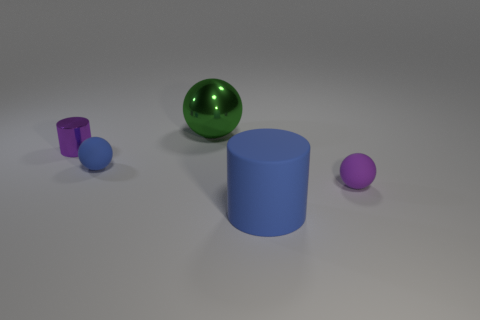There is a blue object that is made of the same material as the blue ball; what shape is it?
Offer a terse response. Cylinder. What is the color of the object that is both on the right side of the tiny purple cylinder and behind the small blue thing?
Your answer should be very brief. Green. Is the material of the purple object right of the large blue thing the same as the green ball?
Give a very brief answer. No. Are there fewer small purple shiny cylinders that are behind the big shiny thing than small metallic things?
Make the answer very short. Yes. Is there a blue ball made of the same material as the large green object?
Make the answer very short. No. Do the purple sphere and the sphere behind the small shiny cylinder have the same size?
Your answer should be very brief. No. Are there any rubber balls of the same color as the big shiny sphere?
Your answer should be compact. No. Are there an equal number of metallic spheres and brown cylinders?
Offer a very short reply. No. Does the green ball have the same material as the big blue cylinder?
Ensure brevity in your answer.  No. What number of small purple matte objects are on the left side of the purple metallic cylinder?
Your answer should be compact. 0. 